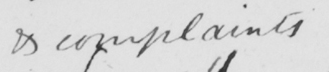What is written in this line of handwriting? & complaints 